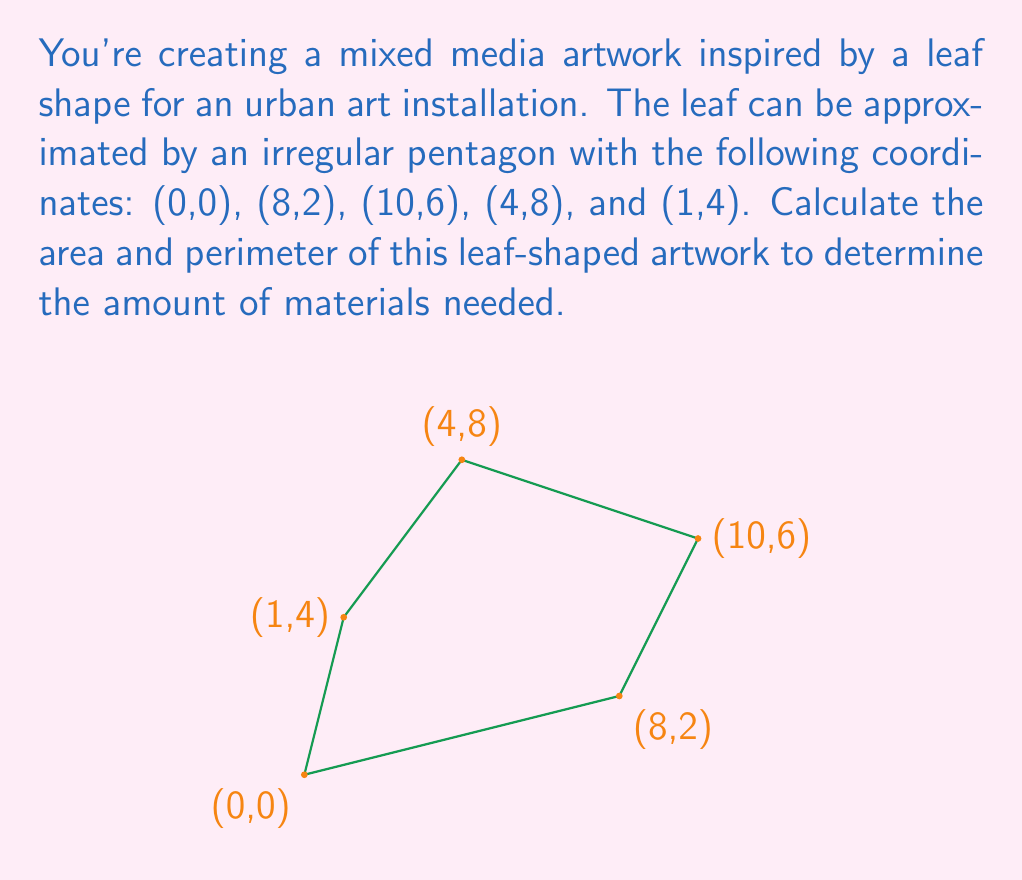Show me your answer to this math problem. To solve this problem, we'll calculate the area using the Shoelace formula and the perimeter by summing the distances between consecutive points.

1. Area calculation using the Shoelace formula:

The Shoelace formula for the area of a polygon with vertices $(x_1, y_1), (x_2, y_2), ..., (x_n, y_n)$ is:

$$A = \frac{1}{2}|x_1y_2 + x_2y_3 + ... + x_ny_1 - y_1x_2 - y_2x_3 - ... - y_nx_1|$$

Applying this to our coordinates:

$$\begin{align*}
A &= \frac{1}{2}|(0 \cdot 2 + 8 \cdot 6 + 10 \cdot 8 + 4 \cdot 4 + 1 \cdot 0) \\
&\quad - (0 \cdot 8 + 2 \cdot 10 + 6 \cdot 4 + 8 \cdot 1 + 4 \cdot 0)| \\
&= \frac{1}{2}|(0 + 48 + 80 + 16 + 0) - (0 + 20 + 24 + 8 + 0)| \\
&= \frac{1}{2}|144 - 52| \\
&= \frac{1}{2} \cdot 92 \\
&= 46
\end{align*}$$

2. Perimeter calculation:

To find the perimeter, we'll calculate the distance between each pair of consecutive points using the distance formula: $d = \sqrt{(x_2-x_1)^2 + (y_2-y_1)^2}$

$$\begin{align*}
d_{AB} &= \sqrt{(8-0)^2 + (2-0)^2} = \sqrt{68} \\
d_{BC} &= \sqrt{(10-8)^2 + (6-2)^2} = \sqrt{20} \\
d_{CD} &= \sqrt{(4-10)^2 + (8-6)^2} = \sqrt{40} \\
d_{DE} &= \sqrt{(1-4)^2 + (4-8)^2} = 5 \\
d_{EA} &= \sqrt{(0-1)^2 + (0-4)^2} = \sqrt{17}
\end{align*}$$

The perimeter is the sum of these distances:

$$P = \sqrt{68} + \sqrt{20} + \sqrt{40} + 5 + \sqrt{17}$$
Answer: Area: 46 square units
Perimeter: $\sqrt{68} + \sqrt{20} + \sqrt{40} + 5 + \sqrt{17}$ units (approximately 24.07 units) 